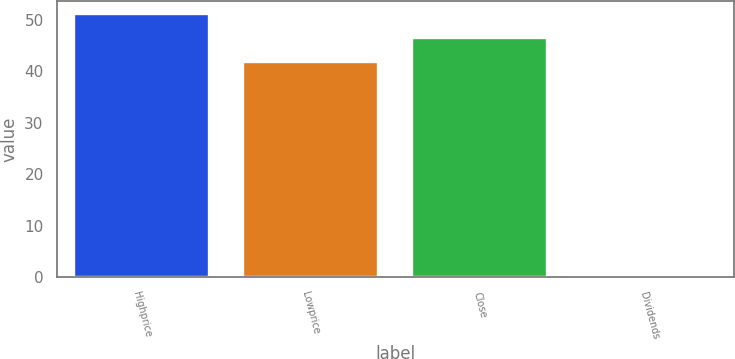<chart> <loc_0><loc_0><loc_500><loc_500><bar_chart><fcel>Highprice<fcel>Lowprice<fcel>Close<fcel>Dividends<nl><fcel>51.13<fcel>41.77<fcel>46.45<fcel>0.4<nl></chart> 